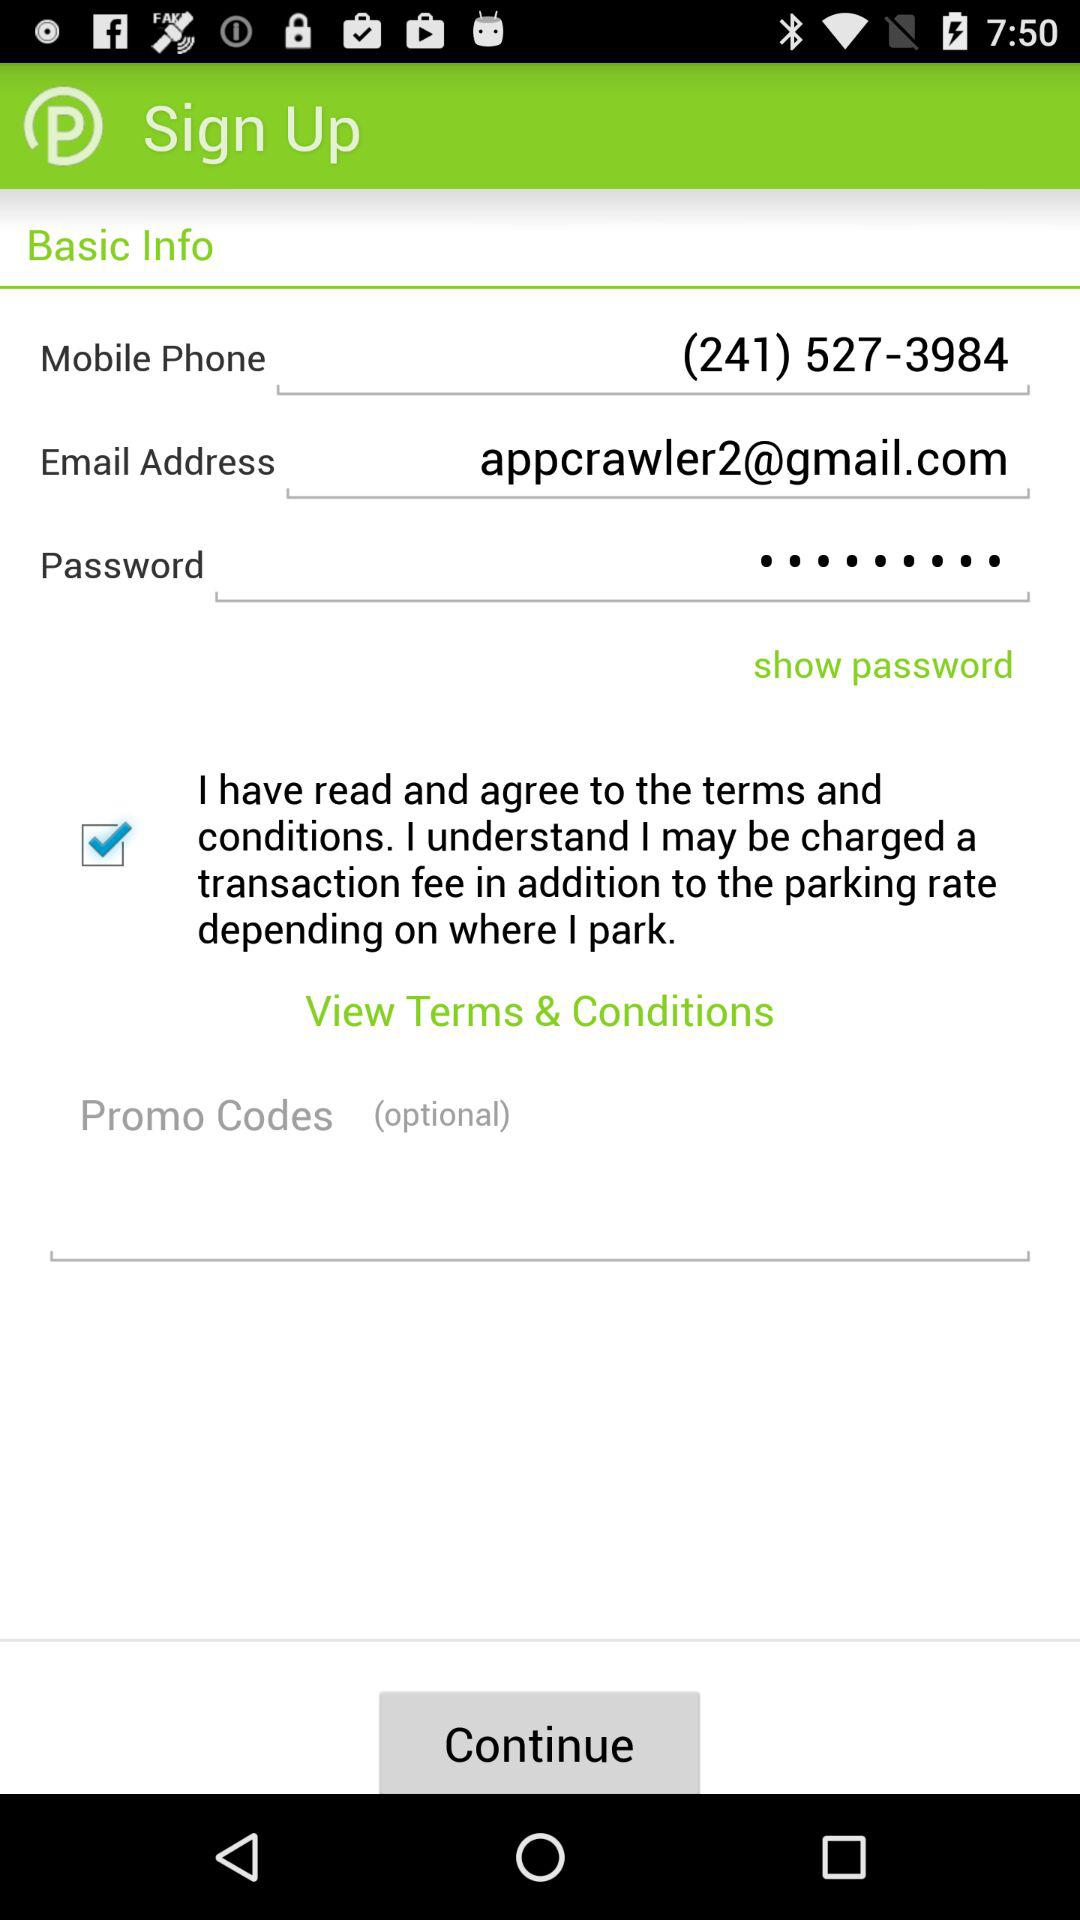What is the email address? The email address is appcrawler2@gmail.com. 